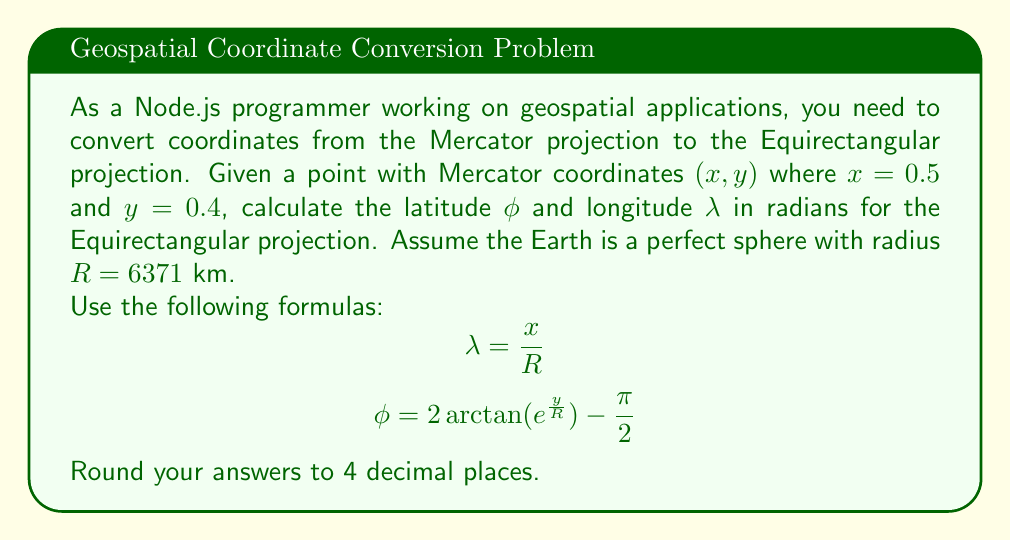What is the answer to this math problem? To solve this problem, we'll follow these steps:

1) First, let's calculate the longitude $\lambda$:
   $$\lambda = \frac{x}{R} = \frac{0.5}{6371} \approx 0.0000785 \text{ radians}$$

2) Next, we'll calculate the latitude $\phi$ using the given formula:
   $$\phi = 2 \arctan(e^{\frac{y}{R}}) - \frac{\pi}{2}$$

   Let's break this down:
   a) Calculate $\frac{y}{R}$:
      $$\frac{y}{R} = \frac{0.4}{6371} \approx 0.0000628$$

   b) Calculate $e^{\frac{y}{R}}$:
      $$e^{\frac{y}{R}} \approx e^{0.0000628} \approx 1.0000628$$

   c) Calculate $2 \arctan(e^{\frac{y}{R}})$:
      $$2 \arctan(1.0000628) \approx 2 * 0.7854282 \approx 1.5708564$$

   d) Subtract $\frac{\pi}{2}$:
      $$\phi = 1.5708564 - \frac{\pi}{2} \approx 0.0000564 \text{ radians}$$

3) Rounding both results to 4 decimal places:
   $\lambda \approx 0.0001 \text{ radians}$
   $\phi \approx 0.0001 \text{ radians}$
Answer: $\lambda \approx 0.0001 \text{ radians}$, $\phi \approx 0.0001 \text{ radians}$ 